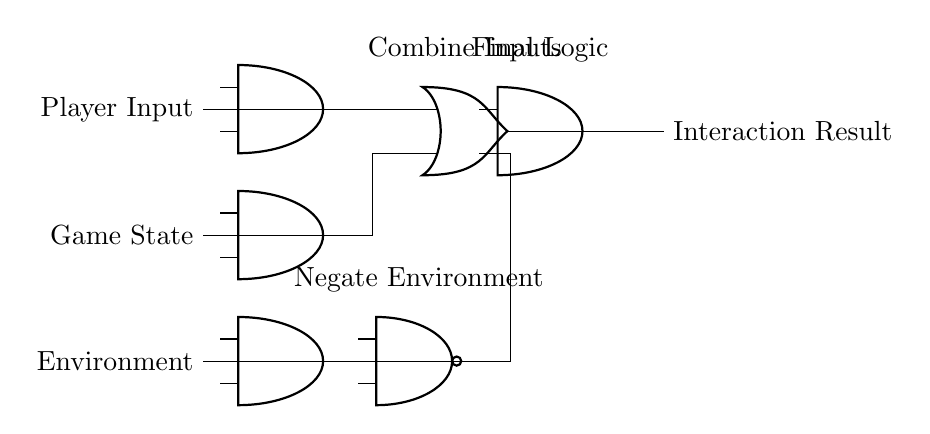What three inputs are used in this logic gate circuit? The circuit has three inputs: Player Input, Game State, and Environment. They are connected to the three AND gates at the start of the circuit.
Answer: Player Input, Game State, Environment What type of logic gates are used in this circuit? The circuit uses AND, OR, and NAND gates. AND gates are used for combining inputs, the OR gate combines outputs from the AND gates, and the NAND gate negates the Environment signal.
Answer: AND, OR, NAND How many layers of logic gates are present in the circuit? The circuit has two layers of logic gates: the first layer consists of three AND gates and one OR gate, while the second layer consists of one AND gate and one NAND gate.
Answer: Two layers What is the purpose of the OR gate in this circuit? The OR gate combines the outputs of the two AND gates to provide a single signal that can be further processed in the circuit, which helps in determining the final interaction result.
Answer: Combine Inputs What is the output of the circuit? The output of the circuit is the Interaction Result, which is determined by the combined logic of the inputs processed through the series of gates.
Answer: Interaction Result What does the NAND gate do in the circuit? The NAND gate negates the Environment input, which means that if the Environment input is high, the output from the NAND gate will be low, allowing for more accurate player interactions based on environmental factors.
Answer: Negate Environment What is the final function of this logic gate circuit? The final function of the circuit is to process multiple player interactions based on the inputs and to produce a single output result that represents player interactions in the game environment.
Answer: Simulating player interactions 